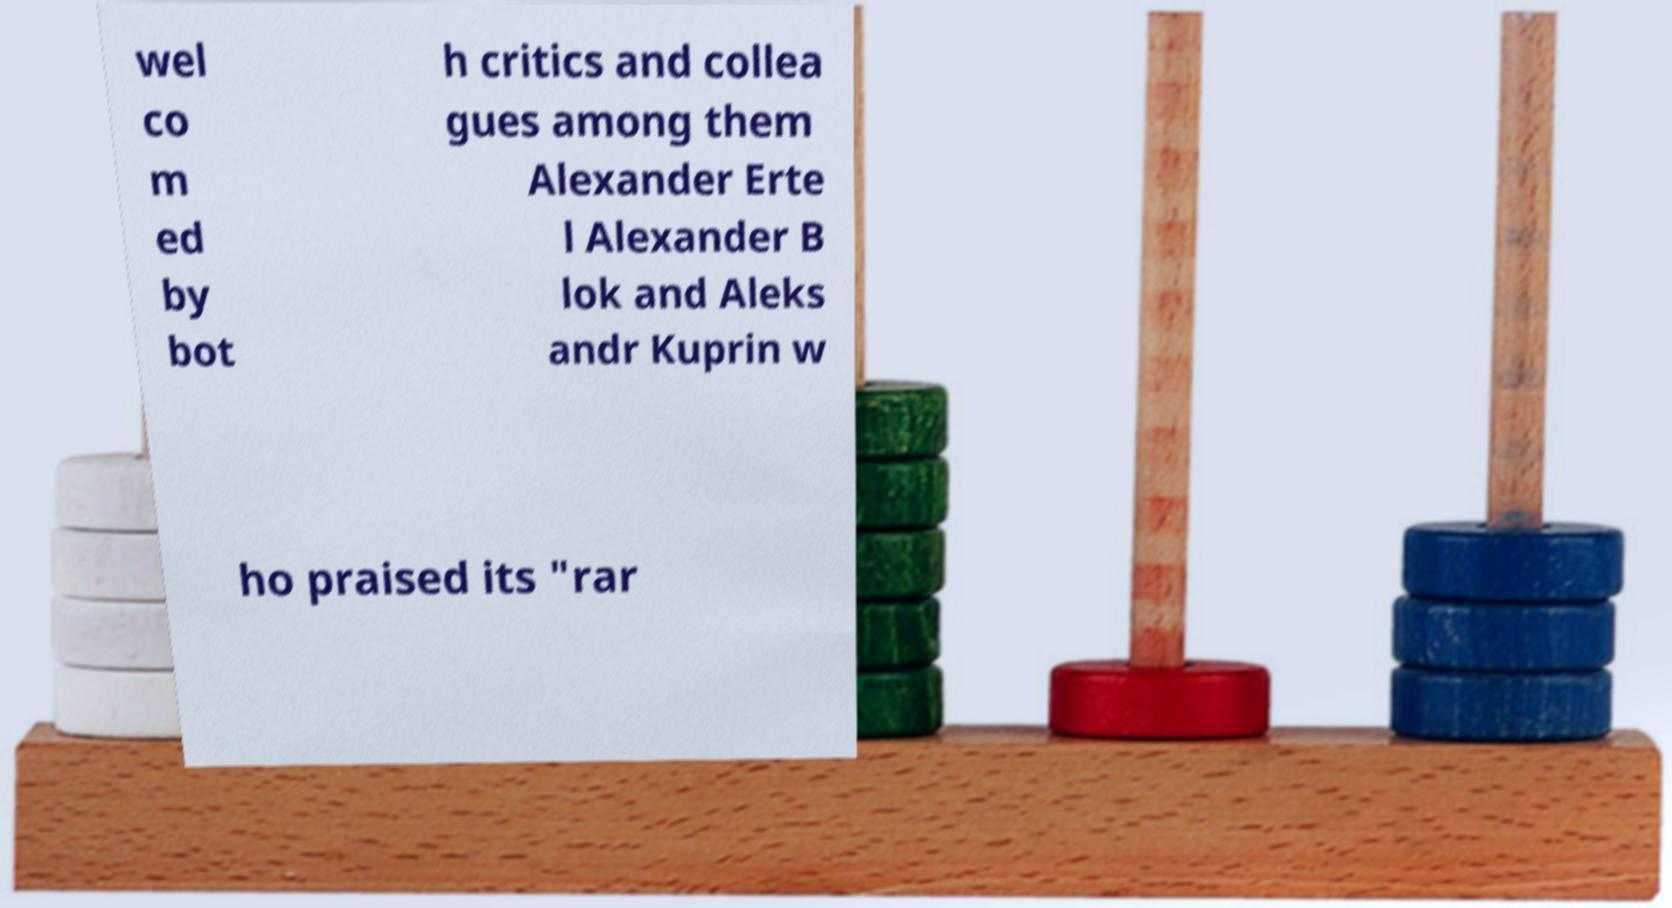What messages or text are displayed in this image? I need them in a readable, typed format. wel co m ed by bot h critics and collea gues among them Alexander Erte l Alexander B lok and Aleks andr Kuprin w ho praised its "rar 